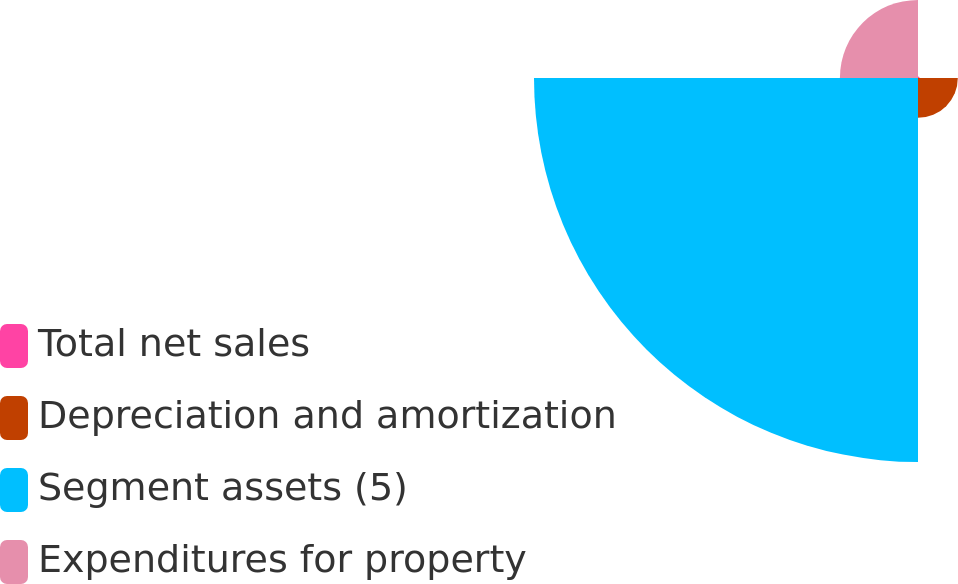Convert chart to OTSL. <chart><loc_0><loc_0><loc_500><loc_500><pie_chart><fcel>Total net sales<fcel>Depreciation and amortization<fcel>Segment assets (5)<fcel>Expenditures for property<nl><fcel>0.31%<fcel>7.91%<fcel>76.27%<fcel>15.51%<nl></chart> 